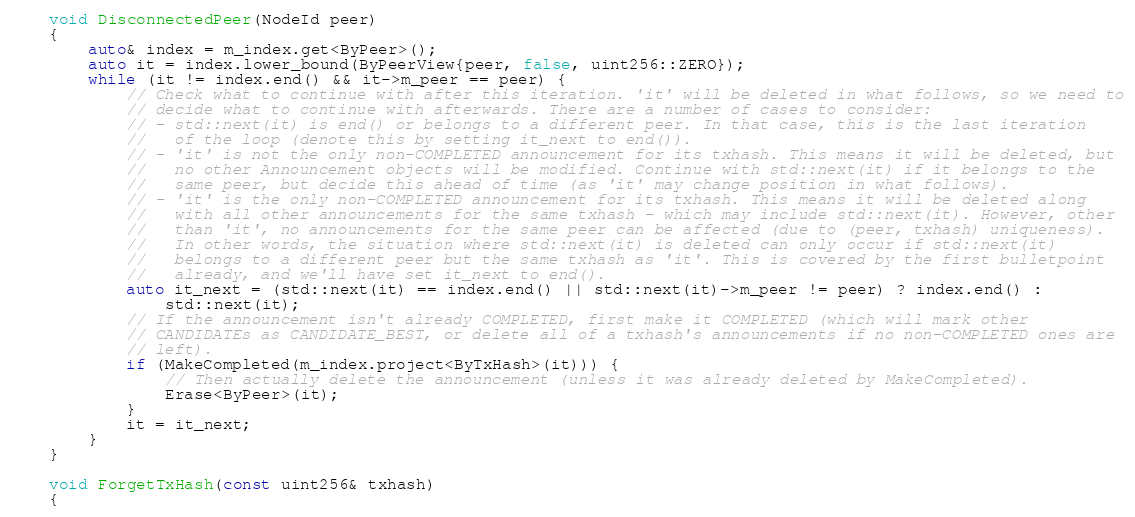Convert code to text. <code><loc_0><loc_0><loc_500><loc_500><_C++_>
    void DisconnectedPeer(NodeId peer)
    {
        auto& index = m_index.get<ByPeer>();
        auto it = index.lower_bound(ByPeerView{peer, false, uint256::ZERO});
        while (it != index.end() && it->m_peer == peer) {
            // Check what to continue with after this iteration. 'it' will be deleted in what follows, so we need to
            // decide what to continue with afterwards. There are a number of cases to consider:
            // - std::next(it) is end() or belongs to a different peer. In that case, this is the last iteration
            //   of the loop (denote this by setting it_next to end()).
            // - 'it' is not the only non-COMPLETED announcement for its txhash. This means it will be deleted, but
            //   no other Announcement objects will be modified. Continue with std::next(it) if it belongs to the
            //   same peer, but decide this ahead of time (as 'it' may change position in what follows).
            // - 'it' is the only non-COMPLETED announcement for its txhash. This means it will be deleted along
            //   with all other announcements for the same txhash - which may include std::next(it). However, other
            //   than 'it', no announcements for the same peer can be affected (due to (peer, txhash) uniqueness).
            //   In other words, the situation where std::next(it) is deleted can only occur if std::next(it)
            //   belongs to a different peer but the same txhash as 'it'. This is covered by the first bulletpoint
            //   already, and we'll have set it_next to end().
            auto it_next = (std::next(it) == index.end() || std::next(it)->m_peer != peer) ? index.end() :
                std::next(it);
            // If the announcement isn't already COMPLETED, first make it COMPLETED (which will mark other
            // CANDIDATEs as CANDIDATE_BEST, or delete all of a txhash's announcements if no non-COMPLETED ones are
            // left).
            if (MakeCompleted(m_index.project<ByTxHash>(it))) {
                // Then actually delete the announcement (unless it was already deleted by MakeCompleted).
                Erase<ByPeer>(it);
            }
            it = it_next;
        }
    }

    void ForgetTxHash(const uint256& txhash)
    {</code> 